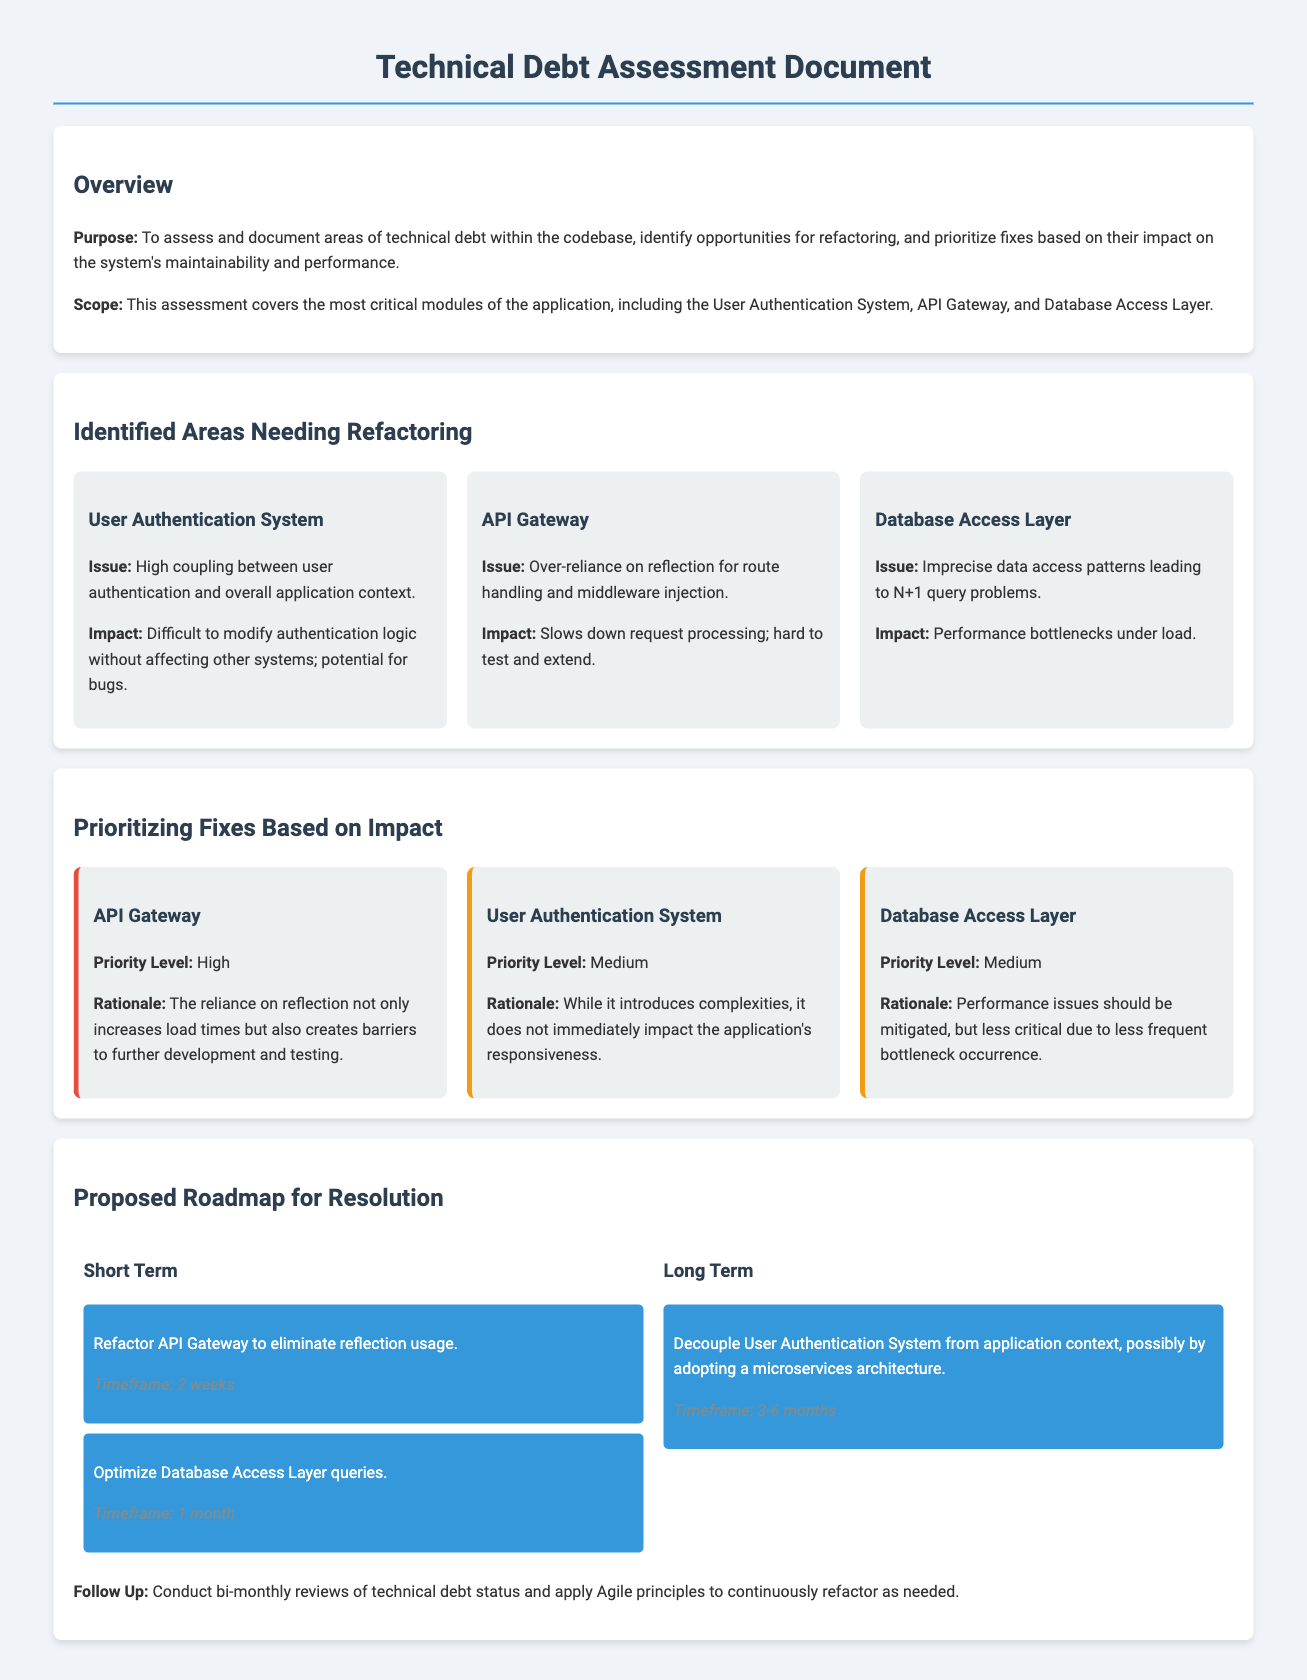What is the purpose of the document? The purpose is to assess and document areas of technical debt within the codebase, identify opportunities for refactoring, and prioritize fixes based on their impact on the system's maintainability and performance.
Answer: To assess and document areas of technical debt Which modules are covered in the assessment? The assessment covers the User Authentication System, API Gateway, and Database Access Layer.
Answer: User Authentication System, API Gateway, Database Access Layer What is the issue identified with the API Gateway? The issue is over-reliance on reflection for route handling and middleware injection.
Answer: Over-reliance on reflection for route handling What is the priority level of the User Authentication System? The priority level is medium.
Answer: Medium What is the proposed timeframe for refactoring the API Gateway? The timeframe for refactoring the API Gateway is 2 weeks.
Answer: 2 weeks What should be done in the short term regarding the Database Access Layer? The task is to optimize Database Access Layer queries.
Answer: Optimize Database Access Layer queries What is the long-term plan for the User Authentication System? The long-term plan is to decouple User Authentication System from application context.
Answer: Decouple from application context When should technical debt reviews be conducted? The follow-up tasks suggest conducting bi-monthly reviews of technical debt status.
Answer: Bi-monthly 